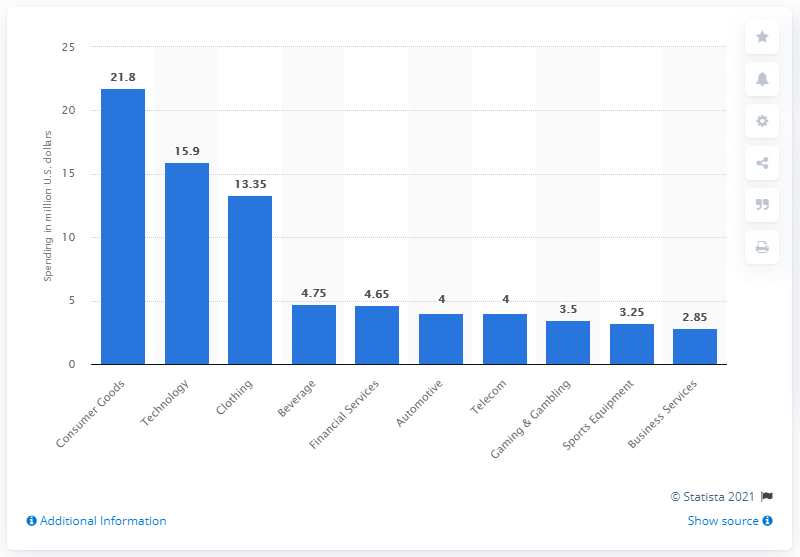Identify some key points in this picture. In 2019, consumer goods brands spent a total of 21.8 dollars on eSports sponsorships. 